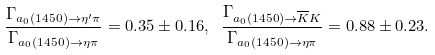Convert formula to latex. <formula><loc_0><loc_0><loc_500><loc_500>\frac { \Gamma _ { a _ { 0 } ( 1 4 5 0 ) \rightarrow \eta ^ { \prime } \pi } } { \Gamma _ { a _ { 0 } ( 1 4 5 0 ) \rightarrow \eta \pi } } = 0 . 3 5 \pm 0 . 1 6 , \text { } \frac { \Gamma _ { a _ { 0 } ( 1 4 5 0 ) \rightarrow \overline { K } K } } { \Gamma _ { a _ { 0 } ( 1 4 5 0 ) \rightarrow \eta \pi } } = 0 . 8 8 \pm 0 . 2 3 .</formula> 